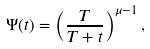Convert formula to latex. <formula><loc_0><loc_0><loc_500><loc_500>\Psi ( t ) = \left ( \frac { T } { T + t } \right ) ^ { \mu - 1 } ,</formula> 